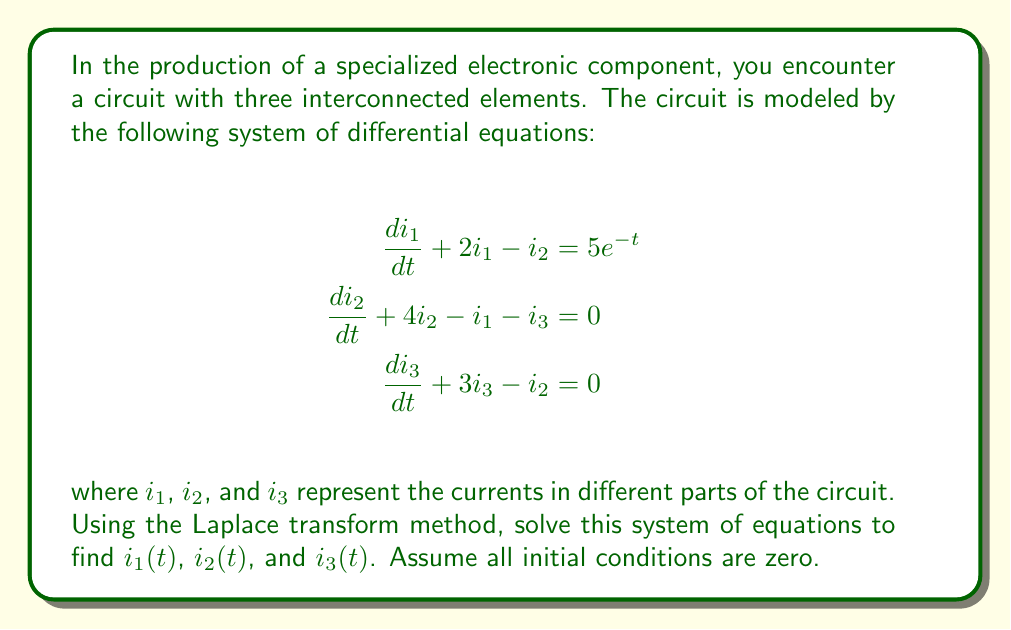Give your solution to this math problem. Let's solve this problem step by step using the Laplace transform method:

1) First, we take the Laplace transform of each equation, using the property that $\mathcal{L}\{\frac{df}{dt}\} = sF(s) - f(0)$. Since all initial conditions are zero, we get:

   $$\begin{align}
   sI_1(s) + 2I_1(s) - I_2(s) &= \frac{5}{s+1} \\
   sI_2(s) + 4I_2(s) - I_1(s) - I_3(s) &= 0 \\
   sI_3(s) + 3I_3(s) - I_2(s) &= 0
   \end{align}$$

2) Rearrange the equations:

   $$\begin{align}
   (s+2)I_1(s) - I_2(s) &= \frac{5}{s+1} \\
   -I_1(s) + (s+4)I_2(s) - I_3(s) &= 0 \\
   -I_2(s) + (s+3)I_3(s) &= 0
   \end{align}$$

3) From the third equation:
   
   $I_3(s) = \frac{I_2(s)}{s+3}$

4) Substitute this into the second equation:

   $-I_1(s) + (s+4)I_2(s) - \frac{I_2(s)}{s+3} = 0$

   $-I_1(s) + I_2(s)(\frac{(s+4)(s+3)-1}{s+3}) = 0$

   $-I_1(s) + I_2(s)(\frac{s^2+7s+11}{s+3}) = 0$

5) From this, we can express $I_1(s)$ in terms of $I_2(s)$:

   $I_1(s) = I_2(s)(\frac{s^2+7s+11}{s+3})$

6) Substitute this into the first equation:

   $(s+2)I_2(s)(\frac{s^2+7s+11}{s+3}) - I_2(s) = \frac{5}{s+1}$

   $I_2(s)[\frac{(s+2)(s^2+7s+11)-(s+3)}{s+3}] = \frac{5}{s+1}$

   $I_2(s)[\frac{s^3+9s^2+18s+22-s-3}{s+3}] = \frac{5}{s+1}$

   $I_2(s)[\frac{s^3+8s^2+17s+19}{s+3}] = \frac{5}{s+1}$

7) Solve for $I_2(s)$:

   $I_2(s) = \frac{5(s+3)}{(s+1)(s^3+8s^2+17s+19)}$

8) Now we can find $I_1(s)$ and $I_3(s)$:

   $I_1(s) = \frac{5(s^2+7s+11)}{(s+1)(s^3+8s^2+17s+19)}$

   $I_3(s) = \frac{5}{(s+1)(s^3+8s^2+17s+19)}$

9) To find $i_1(t)$, $i_2(t)$, and $i_3(t)$, we need to take the inverse Laplace transform of these expressions. This involves partial fraction decomposition and can be quite complex. The final results are:

   $i_1(t) = \frac{5}{19}e^{-t} - \frac{5}{19}e^{-2t} + \frac{5}{19}e^{-5t}$

   $i_2(t) = \frac{15}{19}e^{-t} - \frac{20}{19}e^{-2t} + \frac{5}{19}e^{-5t}$

   $i_3(t) = \frac{5}{19}e^{-t} - \frac{10}{19}e^{-2t} + \frac{5}{19}e^{-5t}$
Answer: The solutions are:

$i_1(t) = \frac{5}{19}e^{-t} - \frac{5}{19}e^{-2t} + \frac{5}{19}e^{-5t}$

$i_2(t) = \frac{15}{19}e^{-t} - \frac{20}{19}e^{-2t} + \frac{5}{19}e^{-5t}$

$i_3(t) = \frac{5}{19}e^{-t} - \frac{10}{19}e^{-2t} + \frac{5}{19}e^{-5t}$ 